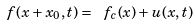Convert formula to latex. <formula><loc_0><loc_0><loc_500><loc_500>\ f ( x + x _ { 0 } , t ) = \ f _ { c } ( x ) + u ( x , t )</formula> 